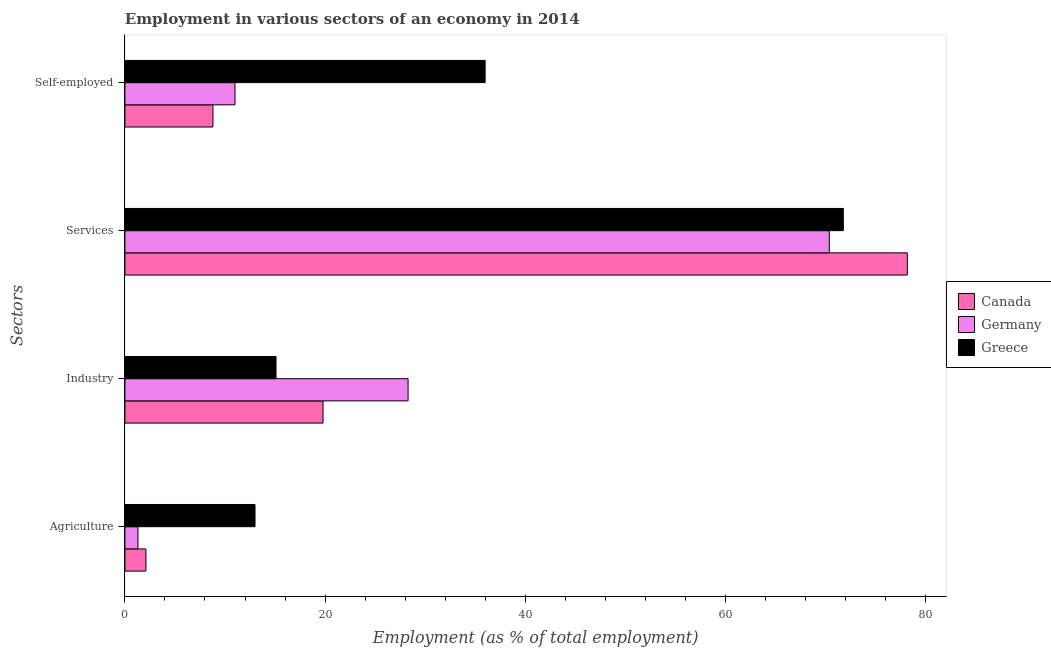How many different coloured bars are there?
Your answer should be compact. 3. How many groups of bars are there?
Provide a succinct answer. 4. How many bars are there on the 4th tick from the bottom?
Ensure brevity in your answer.  3. What is the label of the 3rd group of bars from the top?
Offer a terse response. Industry. What is the percentage of workers in agriculture in Canada?
Offer a terse response. 2.1. Across all countries, what is the maximum percentage of self employed workers?
Keep it short and to the point. 36. Across all countries, what is the minimum percentage of workers in services?
Provide a short and direct response. 70.4. In which country was the percentage of workers in services minimum?
Provide a short and direct response. Germany. What is the total percentage of workers in agriculture in the graph?
Your response must be concise. 16.4. What is the difference between the percentage of workers in industry in Greece and that in Germany?
Your answer should be very brief. -13.2. What is the difference between the percentage of workers in industry in Canada and the percentage of self employed workers in Greece?
Ensure brevity in your answer.  -16.2. What is the average percentage of workers in agriculture per country?
Provide a succinct answer. 5.47. What is the difference between the percentage of workers in industry and percentage of self employed workers in Canada?
Your answer should be very brief. 11. In how many countries, is the percentage of workers in services greater than 76 %?
Make the answer very short. 1. What is the ratio of the percentage of workers in services in Greece to that in Canada?
Give a very brief answer. 0.92. Is the percentage of workers in industry in Canada less than that in Germany?
Your answer should be very brief. Yes. Is the difference between the percentage of workers in agriculture in Greece and Canada greater than the difference between the percentage of workers in industry in Greece and Canada?
Provide a succinct answer. Yes. What is the difference between the highest and the lowest percentage of workers in agriculture?
Offer a terse response. 11.7. In how many countries, is the percentage of self employed workers greater than the average percentage of self employed workers taken over all countries?
Your response must be concise. 1. Is it the case that in every country, the sum of the percentage of workers in services and percentage of workers in agriculture is greater than the sum of percentage of self employed workers and percentage of workers in industry?
Offer a very short reply. Yes. How many bars are there?
Provide a short and direct response. 12. Are the values on the major ticks of X-axis written in scientific E-notation?
Your answer should be very brief. No. Where does the legend appear in the graph?
Make the answer very short. Center right. What is the title of the graph?
Provide a short and direct response. Employment in various sectors of an economy in 2014. Does "Macao" appear as one of the legend labels in the graph?
Provide a short and direct response. No. What is the label or title of the X-axis?
Offer a very short reply. Employment (as % of total employment). What is the label or title of the Y-axis?
Your answer should be compact. Sectors. What is the Employment (as % of total employment) in Canada in Agriculture?
Ensure brevity in your answer.  2.1. What is the Employment (as % of total employment) of Germany in Agriculture?
Your response must be concise. 1.3. What is the Employment (as % of total employment) in Greece in Agriculture?
Provide a succinct answer. 13. What is the Employment (as % of total employment) in Canada in Industry?
Provide a short and direct response. 19.8. What is the Employment (as % of total employment) in Germany in Industry?
Your answer should be very brief. 28.3. What is the Employment (as % of total employment) of Greece in Industry?
Your answer should be compact. 15.1. What is the Employment (as % of total employment) in Canada in Services?
Your response must be concise. 78.2. What is the Employment (as % of total employment) in Germany in Services?
Your response must be concise. 70.4. What is the Employment (as % of total employment) of Greece in Services?
Keep it short and to the point. 71.8. What is the Employment (as % of total employment) in Canada in Self-employed?
Offer a very short reply. 8.8. What is the Employment (as % of total employment) of Germany in Self-employed?
Your response must be concise. 11. Across all Sectors, what is the maximum Employment (as % of total employment) in Canada?
Offer a terse response. 78.2. Across all Sectors, what is the maximum Employment (as % of total employment) in Germany?
Ensure brevity in your answer.  70.4. Across all Sectors, what is the maximum Employment (as % of total employment) of Greece?
Ensure brevity in your answer.  71.8. Across all Sectors, what is the minimum Employment (as % of total employment) of Canada?
Your response must be concise. 2.1. Across all Sectors, what is the minimum Employment (as % of total employment) of Germany?
Ensure brevity in your answer.  1.3. Across all Sectors, what is the minimum Employment (as % of total employment) in Greece?
Offer a very short reply. 13. What is the total Employment (as % of total employment) in Canada in the graph?
Your response must be concise. 108.9. What is the total Employment (as % of total employment) of Germany in the graph?
Your response must be concise. 111. What is the total Employment (as % of total employment) in Greece in the graph?
Your answer should be compact. 135.9. What is the difference between the Employment (as % of total employment) in Canada in Agriculture and that in Industry?
Your answer should be compact. -17.7. What is the difference between the Employment (as % of total employment) in Greece in Agriculture and that in Industry?
Give a very brief answer. -2.1. What is the difference between the Employment (as % of total employment) of Canada in Agriculture and that in Services?
Provide a short and direct response. -76.1. What is the difference between the Employment (as % of total employment) of Germany in Agriculture and that in Services?
Your answer should be compact. -69.1. What is the difference between the Employment (as % of total employment) of Greece in Agriculture and that in Services?
Offer a terse response. -58.8. What is the difference between the Employment (as % of total employment) of Canada in Agriculture and that in Self-employed?
Make the answer very short. -6.7. What is the difference between the Employment (as % of total employment) in Germany in Agriculture and that in Self-employed?
Make the answer very short. -9.7. What is the difference between the Employment (as % of total employment) of Canada in Industry and that in Services?
Your answer should be compact. -58.4. What is the difference between the Employment (as % of total employment) in Germany in Industry and that in Services?
Your answer should be compact. -42.1. What is the difference between the Employment (as % of total employment) in Greece in Industry and that in Services?
Keep it short and to the point. -56.7. What is the difference between the Employment (as % of total employment) of Germany in Industry and that in Self-employed?
Give a very brief answer. 17.3. What is the difference between the Employment (as % of total employment) of Greece in Industry and that in Self-employed?
Give a very brief answer. -20.9. What is the difference between the Employment (as % of total employment) in Canada in Services and that in Self-employed?
Offer a terse response. 69.4. What is the difference between the Employment (as % of total employment) of Germany in Services and that in Self-employed?
Give a very brief answer. 59.4. What is the difference between the Employment (as % of total employment) in Greece in Services and that in Self-employed?
Ensure brevity in your answer.  35.8. What is the difference between the Employment (as % of total employment) of Canada in Agriculture and the Employment (as % of total employment) of Germany in Industry?
Offer a terse response. -26.2. What is the difference between the Employment (as % of total employment) in Canada in Agriculture and the Employment (as % of total employment) in Germany in Services?
Provide a short and direct response. -68.3. What is the difference between the Employment (as % of total employment) of Canada in Agriculture and the Employment (as % of total employment) of Greece in Services?
Your answer should be compact. -69.7. What is the difference between the Employment (as % of total employment) of Germany in Agriculture and the Employment (as % of total employment) of Greece in Services?
Your answer should be very brief. -70.5. What is the difference between the Employment (as % of total employment) of Canada in Agriculture and the Employment (as % of total employment) of Germany in Self-employed?
Keep it short and to the point. -8.9. What is the difference between the Employment (as % of total employment) of Canada in Agriculture and the Employment (as % of total employment) of Greece in Self-employed?
Offer a very short reply. -33.9. What is the difference between the Employment (as % of total employment) in Germany in Agriculture and the Employment (as % of total employment) in Greece in Self-employed?
Ensure brevity in your answer.  -34.7. What is the difference between the Employment (as % of total employment) of Canada in Industry and the Employment (as % of total employment) of Germany in Services?
Your answer should be very brief. -50.6. What is the difference between the Employment (as % of total employment) of Canada in Industry and the Employment (as % of total employment) of Greece in Services?
Your answer should be compact. -52. What is the difference between the Employment (as % of total employment) of Germany in Industry and the Employment (as % of total employment) of Greece in Services?
Your answer should be compact. -43.5. What is the difference between the Employment (as % of total employment) of Canada in Industry and the Employment (as % of total employment) of Greece in Self-employed?
Your response must be concise. -16.2. What is the difference between the Employment (as % of total employment) of Germany in Industry and the Employment (as % of total employment) of Greece in Self-employed?
Give a very brief answer. -7.7. What is the difference between the Employment (as % of total employment) of Canada in Services and the Employment (as % of total employment) of Germany in Self-employed?
Offer a very short reply. 67.2. What is the difference between the Employment (as % of total employment) of Canada in Services and the Employment (as % of total employment) of Greece in Self-employed?
Keep it short and to the point. 42.2. What is the difference between the Employment (as % of total employment) of Germany in Services and the Employment (as % of total employment) of Greece in Self-employed?
Your response must be concise. 34.4. What is the average Employment (as % of total employment) in Canada per Sectors?
Your answer should be compact. 27.23. What is the average Employment (as % of total employment) of Germany per Sectors?
Provide a succinct answer. 27.75. What is the average Employment (as % of total employment) of Greece per Sectors?
Your response must be concise. 33.98. What is the difference between the Employment (as % of total employment) in Canada and Employment (as % of total employment) in Germany in Agriculture?
Offer a very short reply. 0.8. What is the difference between the Employment (as % of total employment) in Canada and Employment (as % of total employment) in Greece in Agriculture?
Make the answer very short. -10.9. What is the difference between the Employment (as % of total employment) in Germany and Employment (as % of total employment) in Greece in Industry?
Your answer should be compact. 13.2. What is the difference between the Employment (as % of total employment) of Canada and Employment (as % of total employment) of Greece in Services?
Ensure brevity in your answer.  6.4. What is the difference between the Employment (as % of total employment) of Canada and Employment (as % of total employment) of Greece in Self-employed?
Provide a short and direct response. -27.2. What is the difference between the Employment (as % of total employment) in Germany and Employment (as % of total employment) in Greece in Self-employed?
Keep it short and to the point. -25. What is the ratio of the Employment (as % of total employment) of Canada in Agriculture to that in Industry?
Offer a terse response. 0.11. What is the ratio of the Employment (as % of total employment) of Germany in Agriculture to that in Industry?
Your response must be concise. 0.05. What is the ratio of the Employment (as % of total employment) of Greece in Agriculture to that in Industry?
Give a very brief answer. 0.86. What is the ratio of the Employment (as % of total employment) of Canada in Agriculture to that in Services?
Keep it short and to the point. 0.03. What is the ratio of the Employment (as % of total employment) in Germany in Agriculture to that in Services?
Provide a succinct answer. 0.02. What is the ratio of the Employment (as % of total employment) of Greece in Agriculture to that in Services?
Keep it short and to the point. 0.18. What is the ratio of the Employment (as % of total employment) in Canada in Agriculture to that in Self-employed?
Give a very brief answer. 0.24. What is the ratio of the Employment (as % of total employment) in Germany in Agriculture to that in Self-employed?
Offer a very short reply. 0.12. What is the ratio of the Employment (as % of total employment) of Greece in Agriculture to that in Self-employed?
Provide a short and direct response. 0.36. What is the ratio of the Employment (as % of total employment) in Canada in Industry to that in Services?
Offer a very short reply. 0.25. What is the ratio of the Employment (as % of total employment) in Germany in Industry to that in Services?
Keep it short and to the point. 0.4. What is the ratio of the Employment (as % of total employment) of Greece in Industry to that in Services?
Give a very brief answer. 0.21. What is the ratio of the Employment (as % of total employment) of Canada in Industry to that in Self-employed?
Provide a short and direct response. 2.25. What is the ratio of the Employment (as % of total employment) in Germany in Industry to that in Self-employed?
Keep it short and to the point. 2.57. What is the ratio of the Employment (as % of total employment) in Greece in Industry to that in Self-employed?
Make the answer very short. 0.42. What is the ratio of the Employment (as % of total employment) in Canada in Services to that in Self-employed?
Offer a terse response. 8.89. What is the ratio of the Employment (as % of total employment) in Greece in Services to that in Self-employed?
Your answer should be compact. 1.99. What is the difference between the highest and the second highest Employment (as % of total employment) of Canada?
Offer a very short reply. 58.4. What is the difference between the highest and the second highest Employment (as % of total employment) of Germany?
Offer a terse response. 42.1. What is the difference between the highest and the second highest Employment (as % of total employment) of Greece?
Provide a succinct answer. 35.8. What is the difference between the highest and the lowest Employment (as % of total employment) in Canada?
Give a very brief answer. 76.1. What is the difference between the highest and the lowest Employment (as % of total employment) of Germany?
Give a very brief answer. 69.1. What is the difference between the highest and the lowest Employment (as % of total employment) of Greece?
Offer a very short reply. 58.8. 